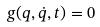<formula> <loc_0><loc_0><loc_500><loc_500>g ( q , \dot { q } , t ) = 0</formula> 